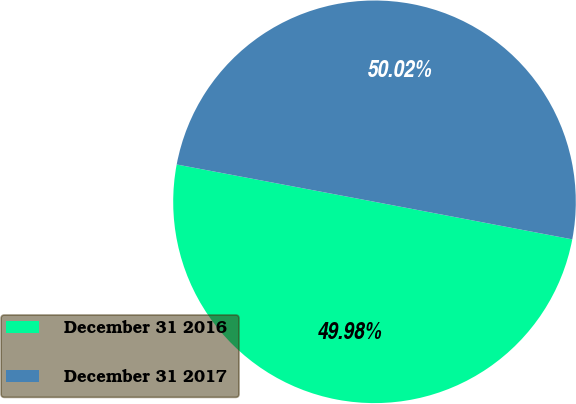Convert chart. <chart><loc_0><loc_0><loc_500><loc_500><pie_chart><fcel>December 31 2016<fcel>December 31 2017<nl><fcel>49.98%<fcel>50.02%<nl></chart> 